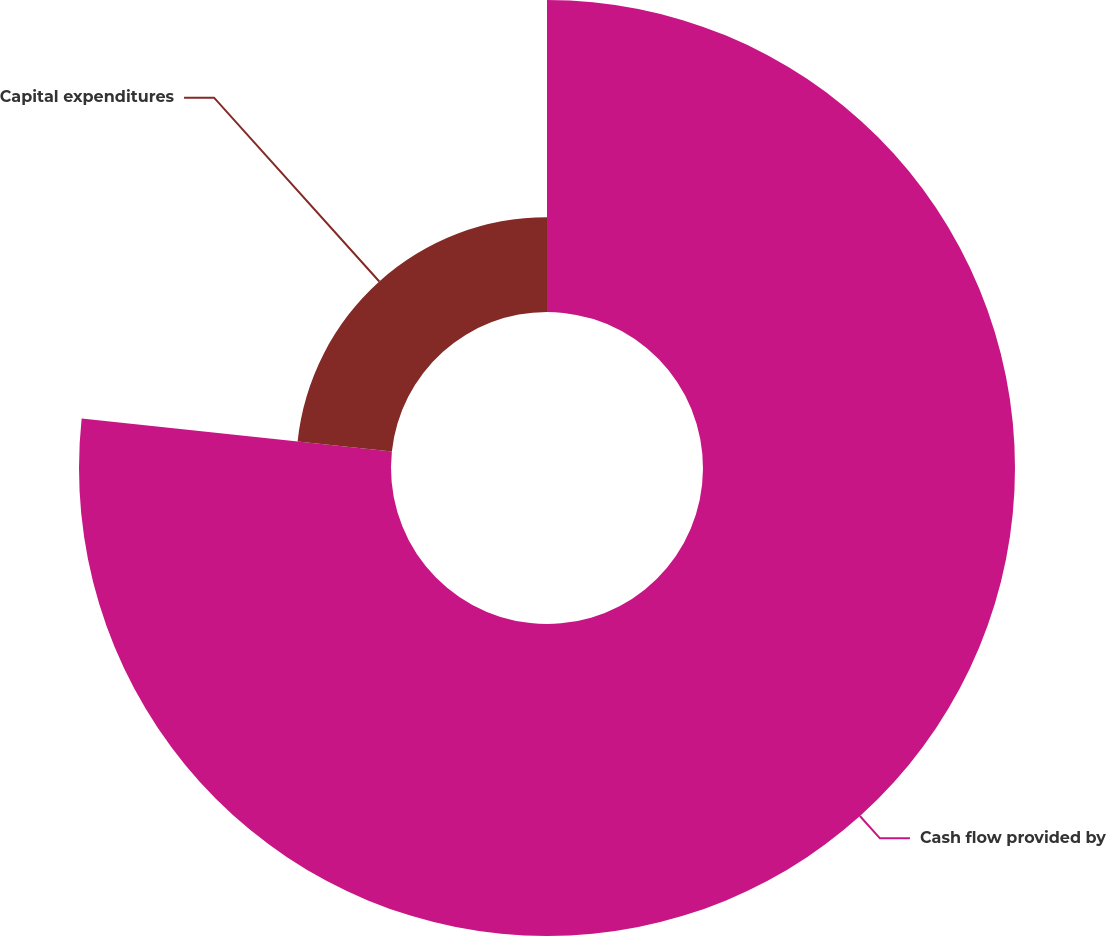Convert chart to OTSL. <chart><loc_0><loc_0><loc_500><loc_500><pie_chart><fcel>Cash flow provided by<fcel>Capital expenditures<nl><fcel>76.69%<fcel>23.31%<nl></chart> 